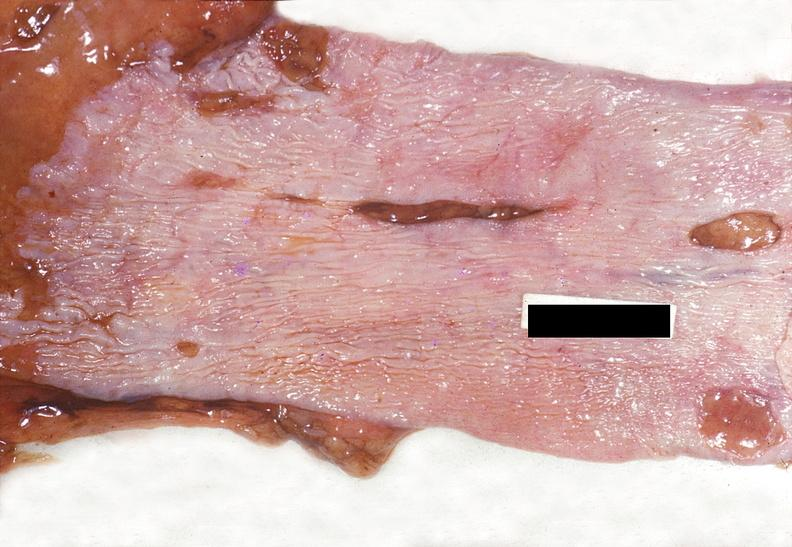does this image show esophagus, mallory-weiss tears?
Answer the question using a single word or phrase. Yes 